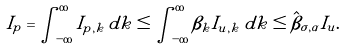<formula> <loc_0><loc_0><loc_500><loc_500>I _ { p } = \int _ { - \infty } ^ { \infty } { I _ { p , k } } \, d k \leq \int _ { - \infty } ^ { \infty } { \beta _ { k } I _ { u , k } } \, d k \leq { \hat { \beta } } _ { \sigma , \alpha } I _ { u } .</formula> 